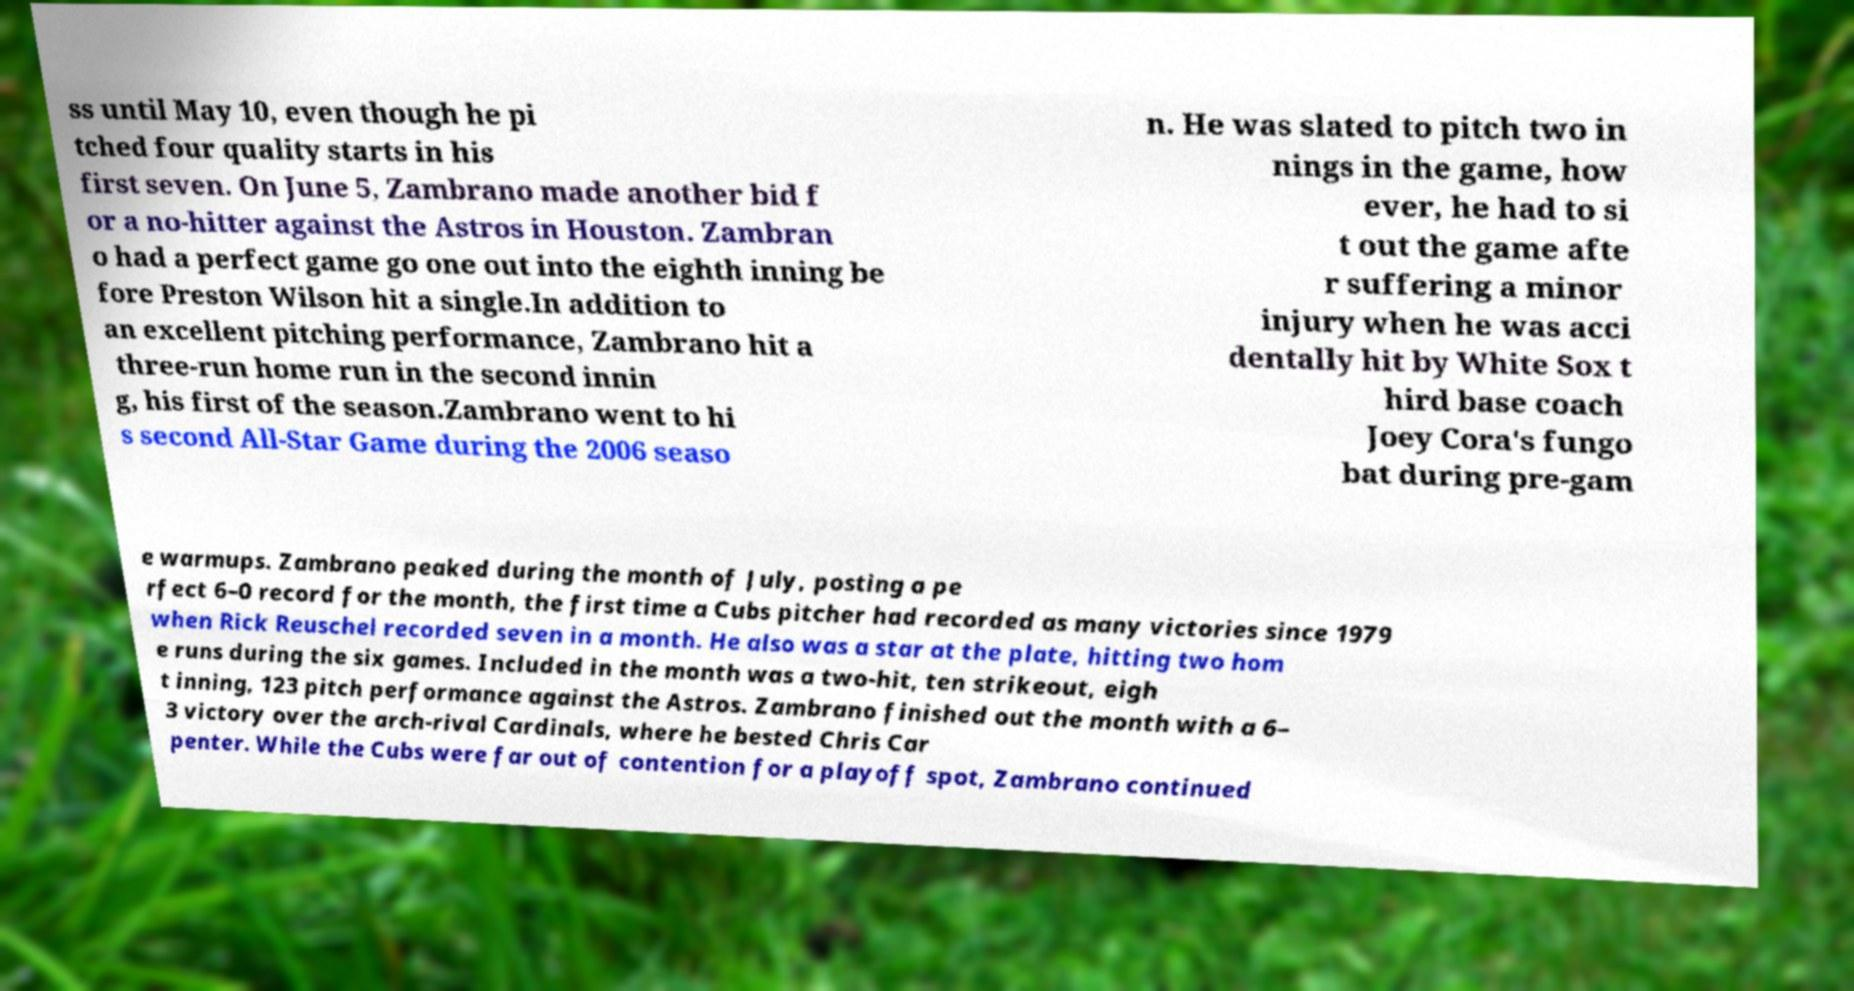I need the written content from this picture converted into text. Can you do that? ss until May 10, even though he pi tched four quality starts in his first seven. On June 5, Zambrano made another bid f or a no-hitter against the Astros in Houston. Zambran o had a perfect game go one out into the eighth inning be fore Preston Wilson hit a single.In addition to an excellent pitching performance, Zambrano hit a three-run home run in the second innin g, his first of the season.Zambrano went to hi s second All-Star Game during the 2006 seaso n. He was slated to pitch two in nings in the game, how ever, he had to si t out the game afte r suffering a minor injury when he was acci dentally hit by White Sox t hird base coach Joey Cora's fungo bat during pre-gam e warmups. Zambrano peaked during the month of July, posting a pe rfect 6–0 record for the month, the first time a Cubs pitcher had recorded as many victories since 1979 when Rick Reuschel recorded seven in a month. He also was a star at the plate, hitting two hom e runs during the six games. Included in the month was a two-hit, ten strikeout, eigh t inning, 123 pitch performance against the Astros. Zambrano finished out the month with a 6– 3 victory over the arch-rival Cardinals, where he bested Chris Car penter. While the Cubs were far out of contention for a playoff spot, Zambrano continued 